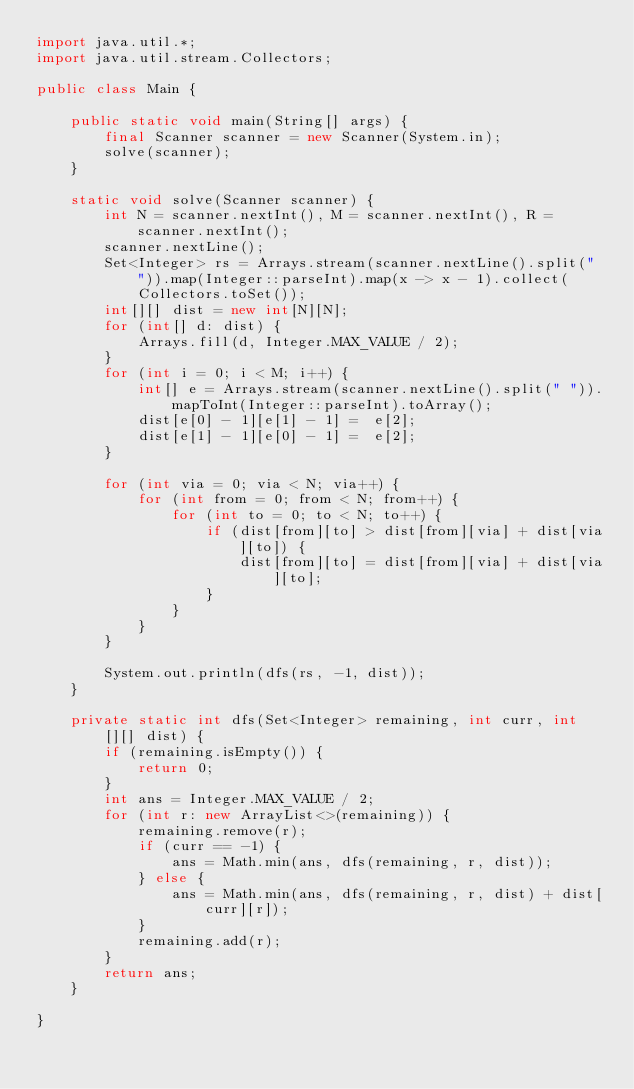Convert code to text. <code><loc_0><loc_0><loc_500><loc_500><_Java_>import java.util.*;
import java.util.stream.Collectors;

public class Main {

    public static void main(String[] args) {
        final Scanner scanner = new Scanner(System.in);
        solve(scanner);
    }

    static void solve(Scanner scanner) {
        int N = scanner.nextInt(), M = scanner.nextInt(), R = scanner.nextInt();
        scanner.nextLine();
        Set<Integer> rs = Arrays.stream(scanner.nextLine().split(" ")).map(Integer::parseInt).map(x -> x - 1).collect(Collectors.toSet());
        int[][] dist = new int[N][N];
        for (int[] d: dist) {
            Arrays.fill(d, Integer.MAX_VALUE / 2);
        }
        for (int i = 0; i < M; i++) {
            int[] e = Arrays.stream(scanner.nextLine().split(" ")).mapToInt(Integer::parseInt).toArray();
            dist[e[0] - 1][e[1] - 1] =  e[2];
            dist[e[1] - 1][e[0] - 1] =  e[2];
        }

        for (int via = 0; via < N; via++) {
            for (int from = 0; from < N; from++) {
                for (int to = 0; to < N; to++) {
                    if (dist[from][to] > dist[from][via] + dist[via][to]) {
                        dist[from][to] = dist[from][via] + dist[via][to];
                    }
                }
            }
        }

        System.out.println(dfs(rs, -1, dist));
    }

    private static int dfs(Set<Integer> remaining, int curr, int[][] dist) {
        if (remaining.isEmpty()) {
            return 0;
        }
        int ans = Integer.MAX_VALUE / 2;
        for (int r: new ArrayList<>(remaining)) {
            remaining.remove(r);
            if (curr == -1) {
                ans = Math.min(ans, dfs(remaining, r, dist));
            } else {
                ans = Math.min(ans, dfs(remaining, r, dist) + dist[curr][r]);
            }
            remaining.add(r);
        }
        return ans;
    }

}</code> 